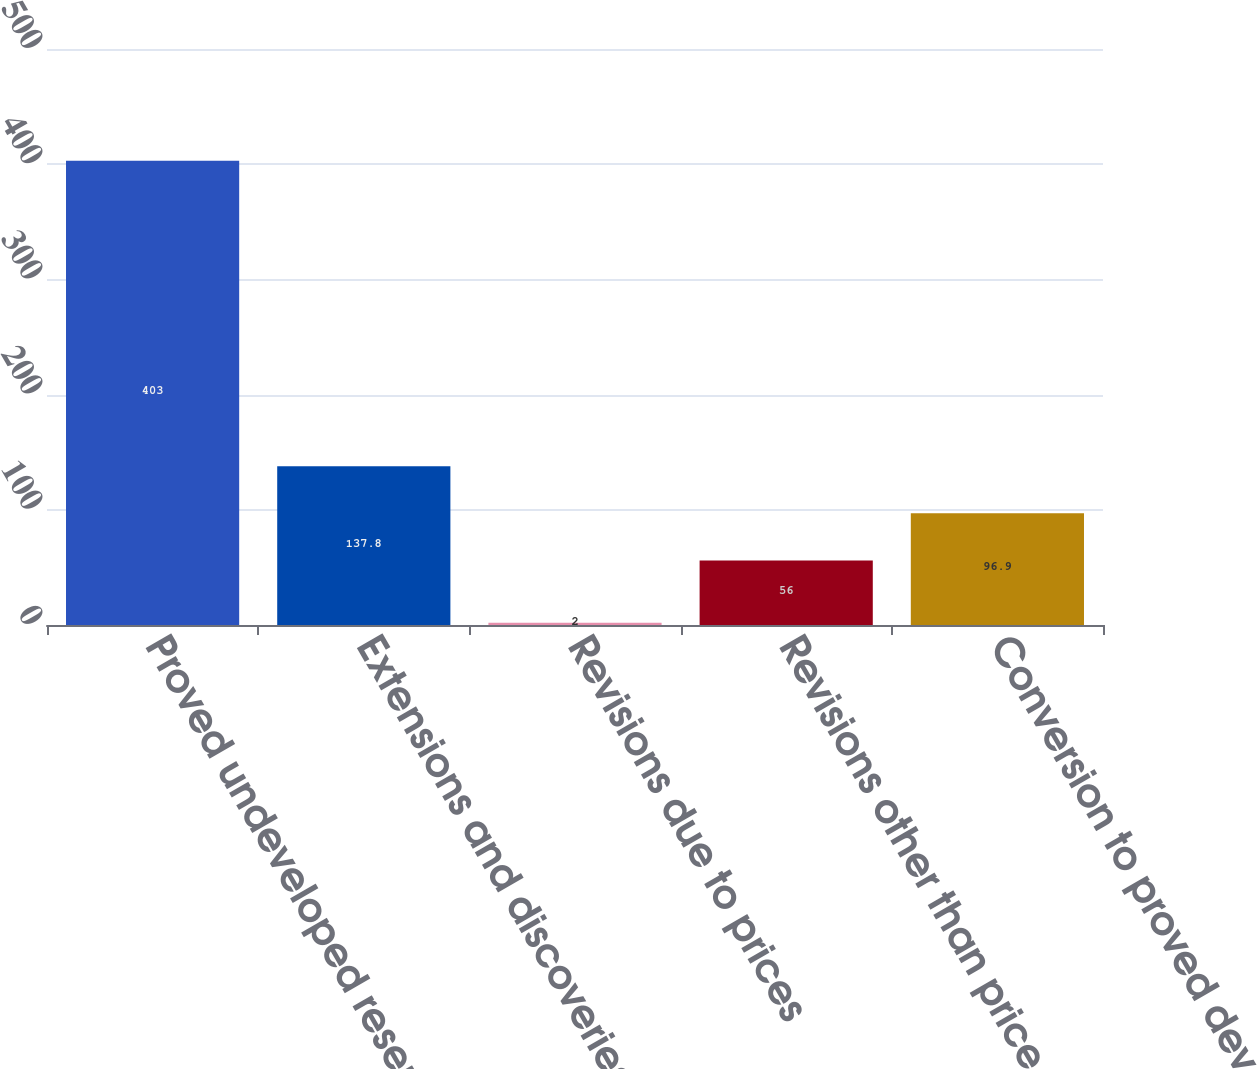<chart> <loc_0><loc_0><loc_500><loc_500><bar_chart><fcel>Proved undeveloped reserves as<fcel>Extensions and discoveries<fcel>Revisions due to prices<fcel>Revisions other than price<fcel>Conversion to proved developed<nl><fcel>403<fcel>137.8<fcel>2<fcel>56<fcel>96.9<nl></chart> 